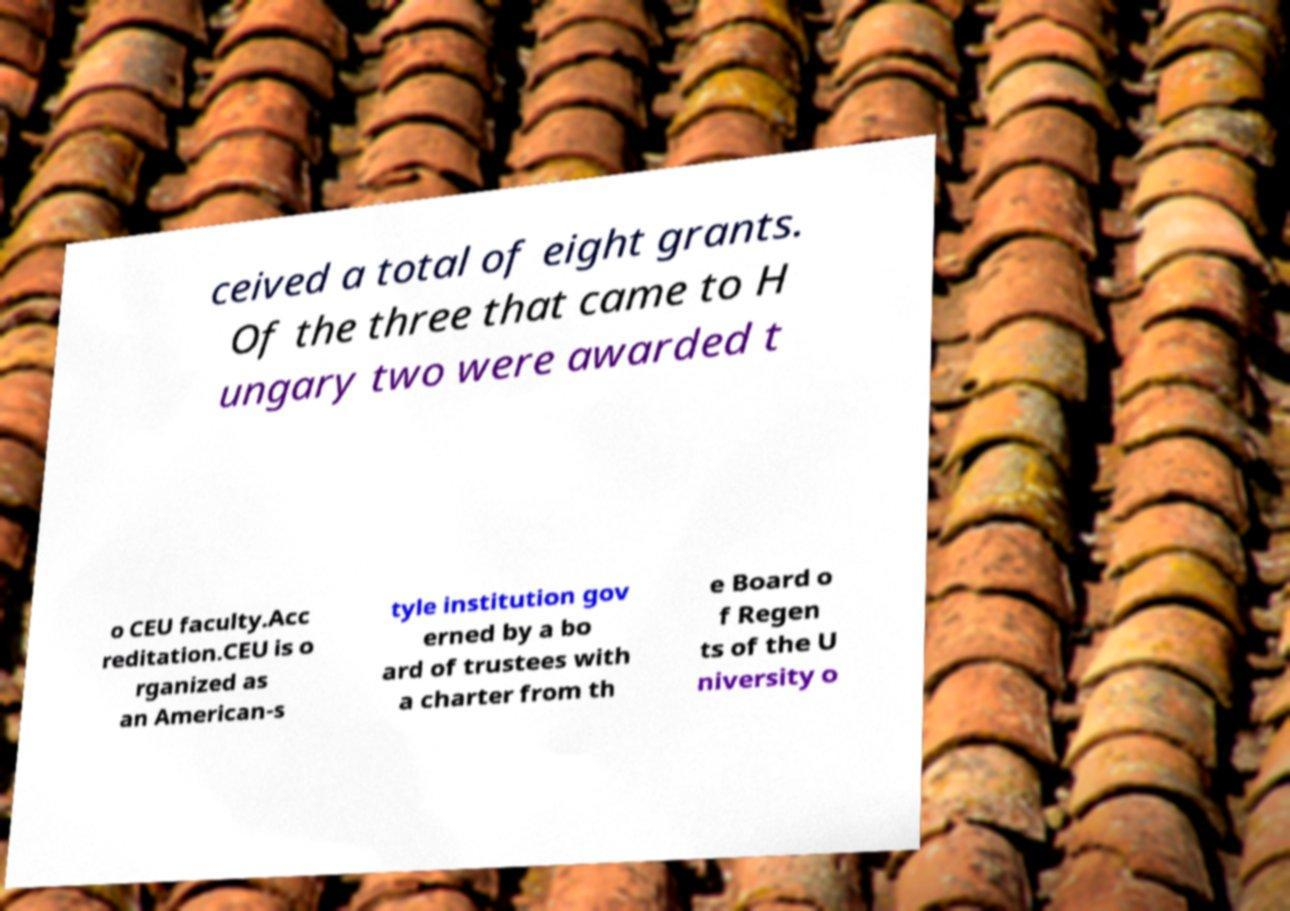What messages or text are displayed in this image? I need them in a readable, typed format. ceived a total of eight grants. Of the three that came to H ungary two were awarded t o CEU faculty.Acc reditation.CEU is o rganized as an American-s tyle institution gov erned by a bo ard of trustees with a charter from th e Board o f Regen ts of the U niversity o 